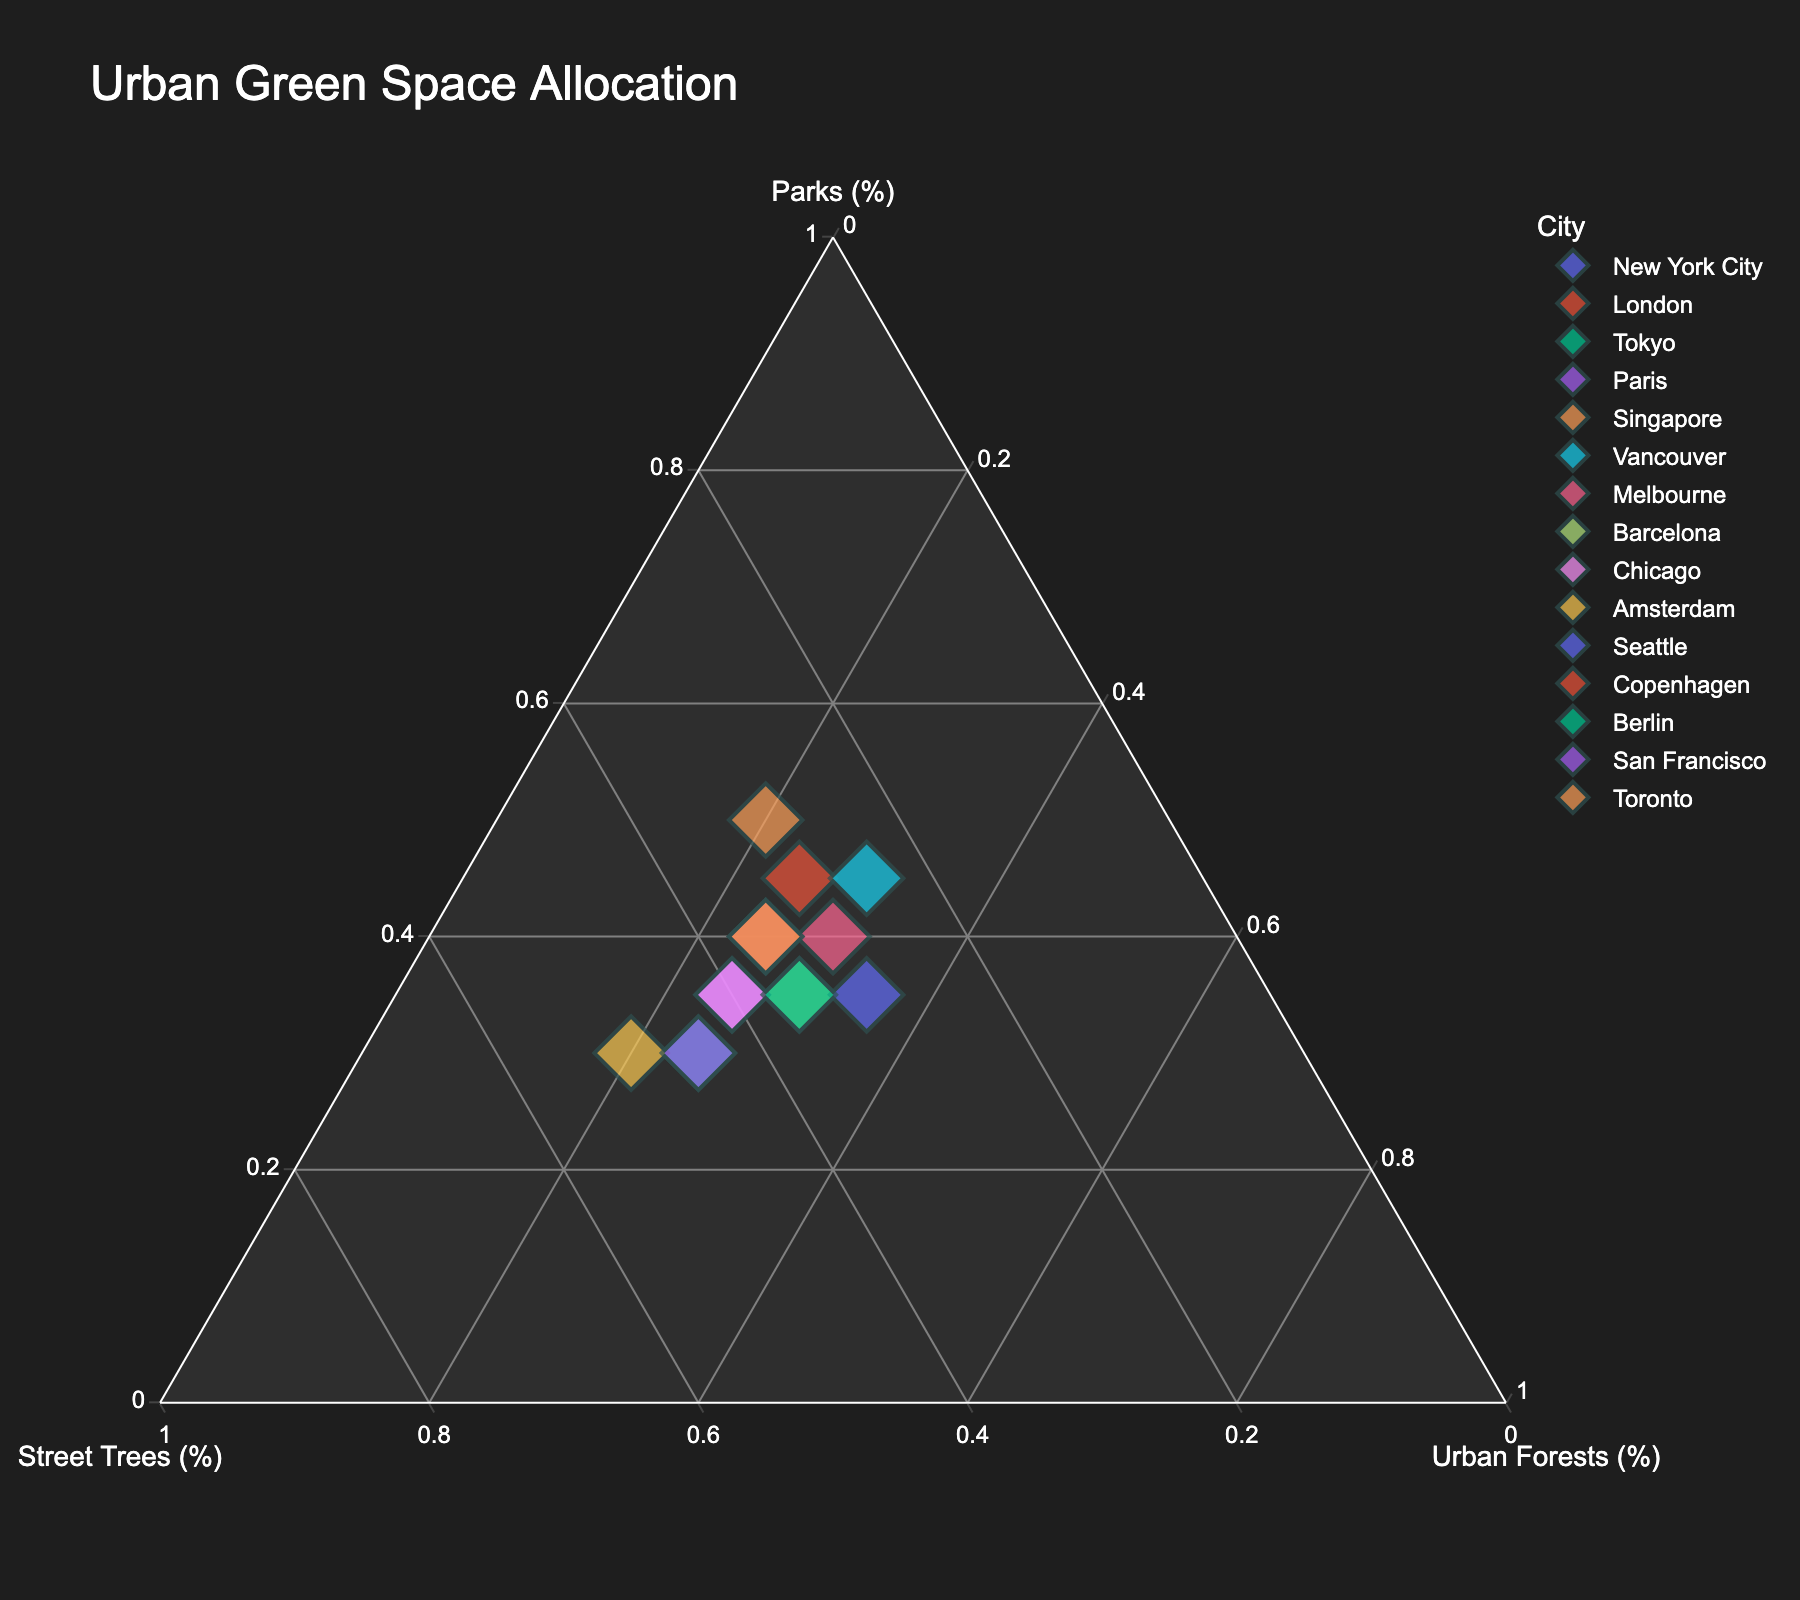What is the title of the figure? The title of the figure is displayed at the top of the plot. It provides an overview of what the plot is about. By reading it, we see the title is "Urban Green Space Allocation".
Answer: Urban Green Space Allocation How many cities are represented in the figure? Each colored marker on the plot represents a city. By counting the markers or by checking the legend, we can determine the number of unique cities represented. In this case, there are 15 different cities.
Answer: 15 Which city has the highest percentage of parks? To determine this, look for the marker that is closest to the "Parks (%)" apex of the ternary plot. Singapore’s marker is positioned nearest to this apex, indicating it has the highest percentage of parks.
Answer: Singapore Which two cities have the same allocation percentages for urban forests? Checking the markers closest to each other on the "Urban Forests (%)" axis, we see that New York City and London both allocate 25% to urban forests.
Answer: New York City and London Which city has the highest allocation for street trees? Locate the marker closest to the "Street Trees (%)" apex. Amsterdam’s marker is positioned nearest to this apex, so it has the highest percentage of street trees.
Answer: Amsterdam What is the median value of the urban forest allocation among all cities? To find the median value, list the percentages for urban forests, which are (25, 25, 25, 25, 25, 25, 25, 25, 20, 30, 30, 30, 30, 35, 25). The median is the middle value, which is 25. To ensure the step-by-step reasoning: Arrange the percentages in ascending order (20, 25, 25, 25, 25, 25, 25, 25, 30, 30, 30, 30, 35), and the middle value is 25.
Answer: 25 Which two cities have similar overall distributions of parks, street trees, and urban forests? Look for markers that are clustered close together on the plot, indicating similar distributions. Paris and Chicago are close to each other, suggesting they have similar distributions among the three categories.
Answer: Paris and Chicago Which city balances the allocation of parks, street trees, and urban forests most evenly? The city marker closest to the center of the ternary plot indicates a balanced allocation. Berlin’s marker is closest to the center, showing it balances its green space allocation most evenly.
Answer: Berlin What percentage of urban forests does Vancouver allocate? Check the position of Vancouver’s marker relative to the "Urban Forests (%)" axis. Its proximity to the axis shows it allocates 30% to urban forests.
Answer: 30 Between Melbourne and Seattle, which city allocates a higher percentage to parks? Compare the positions of Melbourne and Seattle markers relative to the "Parks (%)" axis. Melbourne is positioned closer to the "Parks (%)" apex, meaning it allocates a higher percentage to parks than Seattle.
Answer: Melbourne 